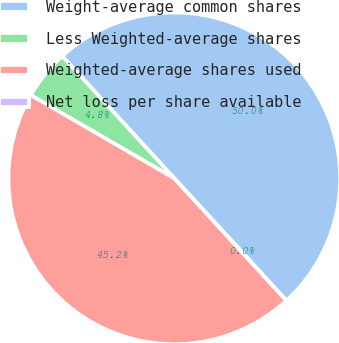Convert chart. <chart><loc_0><loc_0><loc_500><loc_500><pie_chart><fcel>Weight-average common shares<fcel>Less Weighted-average shares<fcel>Weighted-average shares used<fcel>Net loss per share available<nl><fcel>50.0%<fcel>4.83%<fcel>45.17%<fcel>0.0%<nl></chart> 